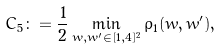<formula> <loc_0><loc_0><loc_500><loc_500>C _ { 5 } \colon = \frac { 1 } { 2 } \min _ { w , w ^ { \prime } \in [ 1 , 4 ] ^ { 2 } } \rho _ { 1 } ( w , w ^ { \prime } ) ,</formula> 